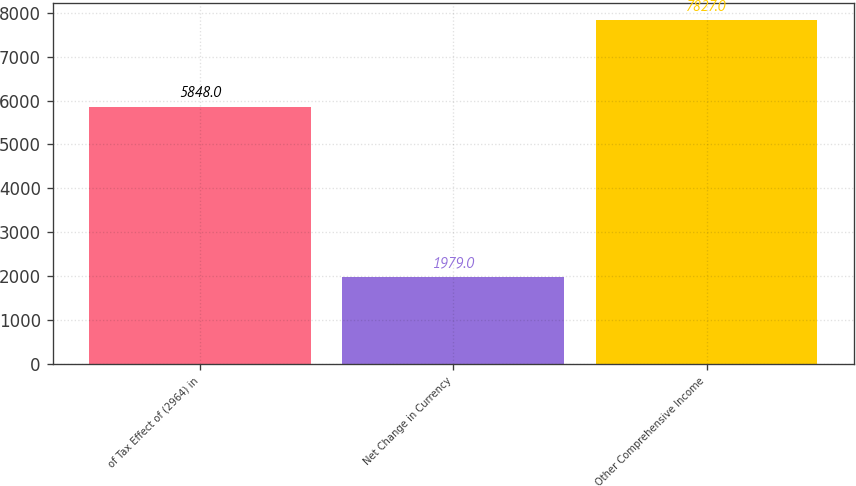Convert chart. <chart><loc_0><loc_0><loc_500><loc_500><bar_chart><fcel>of Tax Effect of (2964) in<fcel>Net Change in Currency<fcel>Other Comprehensive Income<nl><fcel>5848<fcel>1979<fcel>7827<nl></chart> 